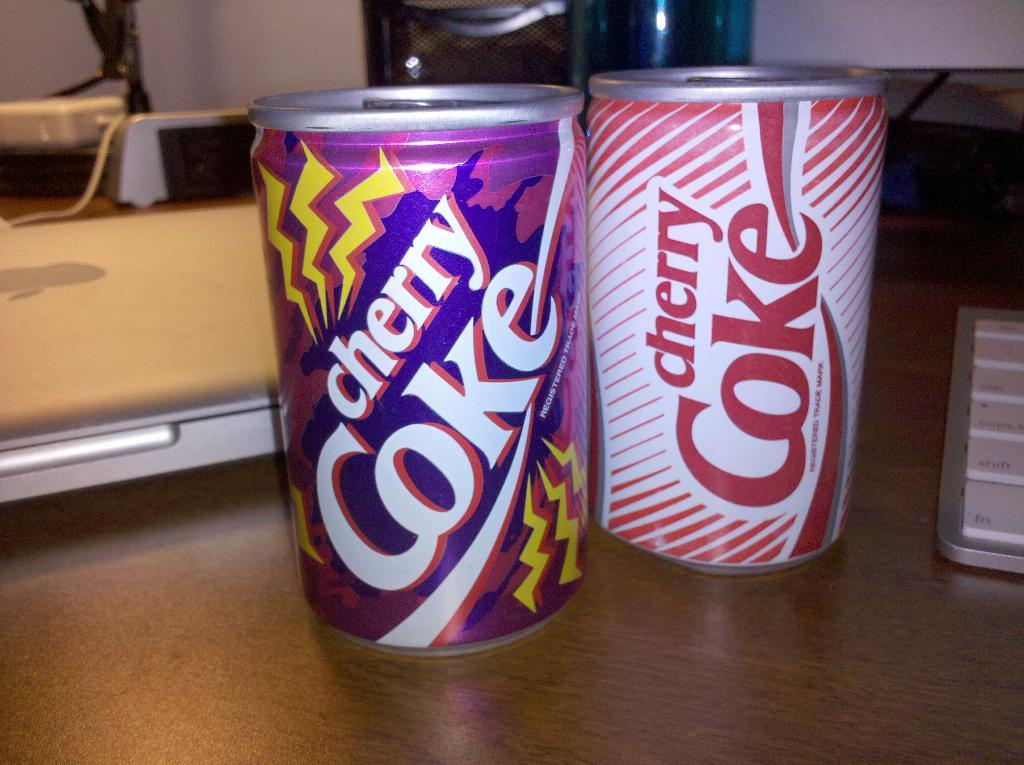<image>
Write a terse but informative summary of the picture. two colorful cans of Cherry Coke sit on a desk 